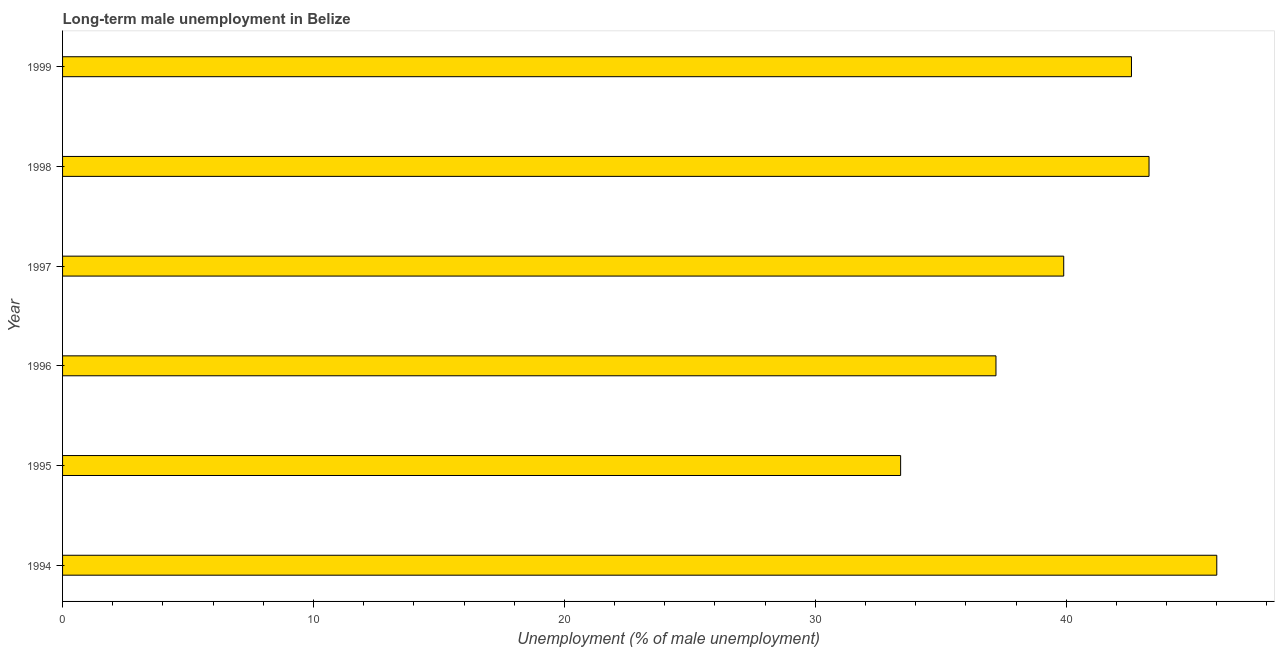Does the graph contain any zero values?
Offer a terse response. No. Does the graph contain grids?
Ensure brevity in your answer.  No. What is the title of the graph?
Provide a succinct answer. Long-term male unemployment in Belize. What is the label or title of the X-axis?
Give a very brief answer. Unemployment (% of male unemployment). What is the label or title of the Y-axis?
Your response must be concise. Year. What is the long-term male unemployment in 1995?
Provide a succinct answer. 33.4. Across all years, what is the minimum long-term male unemployment?
Your response must be concise. 33.4. In which year was the long-term male unemployment maximum?
Make the answer very short. 1994. What is the sum of the long-term male unemployment?
Make the answer very short. 242.4. What is the difference between the long-term male unemployment in 1998 and 1999?
Your answer should be very brief. 0.7. What is the average long-term male unemployment per year?
Offer a terse response. 40.4. What is the median long-term male unemployment?
Offer a terse response. 41.25. Do a majority of the years between 1999 and 1994 (inclusive) have long-term male unemployment greater than 30 %?
Keep it short and to the point. Yes. What is the ratio of the long-term male unemployment in 1997 to that in 1999?
Your answer should be very brief. 0.94. Is the difference between the long-term male unemployment in 1997 and 1999 greater than the difference between any two years?
Give a very brief answer. No. Is the sum of the long-term male unemployment in 1995 and 1998 greater than the maximum long-term male unemployment across all years?
Offer a terse response. Yes. How many years are there in the graph?
Keep it short and to the point. 6. What is the difference between two consecutive major ticks on the X-axis?
Make the answer very short. 10. What is the Unemployment (% of male unemployment) in 1994?
Offer a terse response. 46. What is the Unemployment (% of male unemployment) of 1995?
Offer a terse response. 33.4. What is the Unemployment (% of male unemployment) of 1996?
Offer a very short reply. 37.2. What is the Unemployment (% of male unemployment) in 1997?
Provide a short and direct response. 39.9. What is the Unemployment (% of male unemployment) of 1998?
Ensure brevity in your answer.  43.3. What is the Unemployment (% of male unemployment) in 1999?
Provide a short and direct response. 42.6. What is the difference between the Unemployment (% of male unemployment) in 1994 and 1995?
Make the answer very short. 12.6. What is the difference between the Unemployment (% of male unemployment) in 1995 and 1996?
Your answer should be compact. -3.8. What is the difference between the Unemployment (% of male unemployment) in 1995 and 1997?
Give a very brief answer. -6.5. What is the difference between the Unemployment (% of male unemployment) in 1995 and 1998?
Offer a terse response. -9.9. What is the ratio of the Unemployment (% of male unemployment) in 1994 to that in 1995?
Your response must be concise. 1.38. What is the ratio of the Unemployment (% of male unemployment) in 1994 to that in 1996?
Offer a very short reply. 1.24. What is the ratio of the Unemployment (% of male unemployment) in 1994 to that in 1997?
Make the answer very short. 1.15. What is the ratio of the Unemployment (% of male unemployment) in 1994 to that in 1998?
Your answer should be compact. 1.06. What is the ratio of the Unemployment (% of male unemployment) in 1995 to that in 1996?
Ensure brevity in your answer.  0.9. What is the ratio of the Unemployment (% of male unemployment) in 1995 to that in 1997?
Provide a short and direct response. 0.84. What is the ratio of the Unemployment (% of male unemployment) in 1995 to that in 1998?
Make the answer very short. 0.77. What is the ratio of the Unemployment (% of male unemployment) in 1995 to that in 1999?
Keep it short and to the point. 0.78. What is the ratio of the Unemployment (% of male unemployment) in 1996 to that in 1997?
Make the answer very short. 0.93. What is the ratio of the Unemployment (% of male unemployment) in 1996 to that in 1998?
Keep it short and to the point. 0.86. What is the ratio of the Unemployment (% of male unemployment) in 1996 to that in 1999?
Provide a short and direct response. 0.87. What is the ratio of the Unemployment (% of male unemployment) in 1997 to that in 1998?
Offer a terse response. 0.92. What is the ratio of the Unemployment (% of male unemployment) in 1997 to that in 1999?
Offer a terse response. 0.94. 